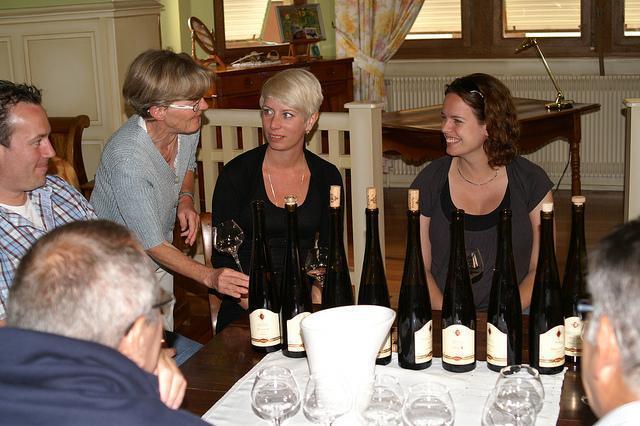How many bottles are on the table?
Give a very brief answer. 9. How many chairs can be seen?
Give a very brief answer. 1. How many bottles can be seen?
Give a very brief answer. 9. How many people are there?
Give a very brief answer. 6. 